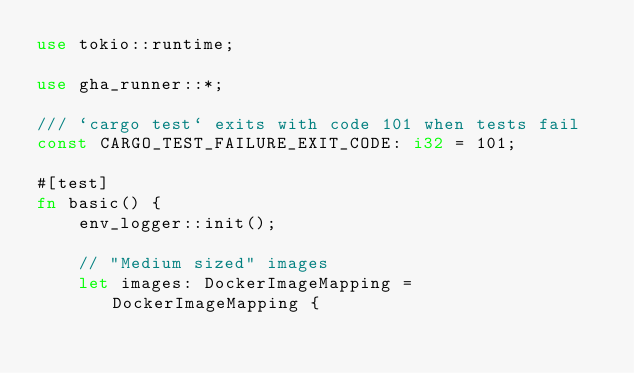<code> <loc_0><loc_0><loc_500><loc_500><_Rust_>use tokio::runtime;

use gha_runner::*;

/// `cargo test` exits with code 101 when tests fail
const CARGO_TEST_FAILURE_EXIT_CODE: i32 = 101;

#[test]
fn basic() {
    env_logger::init();

    // "Medium sized" images
    let images: DockerImageMapping = DockerImageMapping {</code> 